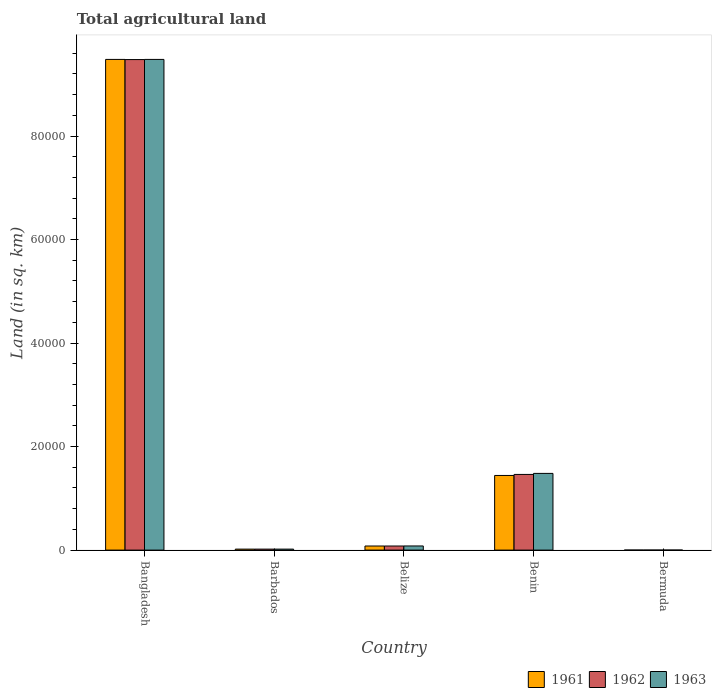How many different coloured bars are there?
Make the answer very short. 3. Are the number of bars on each tick of the X-axis equal?
Your answer should be compact. Yes. What is the label of the 2nd group of bars from the left?
Offer a very short reply. Barbados. What is the total agricultural land in 1963 in Benin?
Provide a short and direct response. 1.48e+04. Across all countries, what is the maximum total agricultural land in 1963?
Offer a very short reply. 9.48e+04. Across all countries, what is the minimum total agricultural land in 1963?
Your answer should be very brief. 3. In which country was the total agricultural land in 1963 maximum?
Provide a short and direct response. Bangladesh. In which country was the total agricultural land in 1961 minimum?
Give a very brief answer. Bermuda. What is the total total agricultural land in 1963 in the graph?
Ensure brevity in your answer.  1.11e+05. What is the difference between the total agricultural land in 1962 in Bangladesh and that in Benin?
Your answer should be compact. 8.02e+04. What is the difference between the total agricultural land in 1963 in Belize and the total agricultural land in 1961 in Bermuda?
Provide a succinct answer. 796. What is the average total agricultural land in 1962 per country?
Provide a short and direct response. 2.21e+04. What is the difference between the total agricultural land of/in 1962 and total agricultural land of/in 1963 in Belize?
Offer a terse response. -10. In how many countries, is the total agricultural land in 1963 greater than 92000 sq.km?
Offer a very short reply. 1. What is the ratio of the total agricultural land in 1962 in Belize to that in Benin?
Offer a very short reply. 0.05. Is the total agricultural land in 1962 in Bangladesh less than that in Bermuda?
Your response must be concise. No. Is the difference between the total agricultural land in 1962 in Bangladesh and Bermuda greater than the difference between the total agricultural land in 1963 in Bangladesh and Bermuda?
Make the answer very short. No. What is the difference between the highest and the second highest total agricultural land in 1962?
Offer a terse response. 8.02e+04. What is the difference between the highest and the lowest total agricultural land in 1963?
Your response must be concise. 9.48e+04. In how many countries, is the total agricultural land in 1962 greater than the average total agricultural land in 1962 taken over all countries?
Offer a very short reply. 1. What does the 1st bar from the left in Belize represents?
Provide a succinct answer. 1961. Are all the bars in the graph horizontal?
Your answer should be compact. No. How many countries are there in the graph?
Provide a succinct answer. 5. Are the values on the major ticks of Y-axis written in scientific E-notation?
Keep it short and to the point. No. Does the graph contain any zero values?
Keep it short and to the point. No. Does the graph contain grids?
Your answer should be compact. No. How are the legend labels stacked?
Make the answer very short. Horizontal. What is the title of the graph?
Give a very brief answer. Total agricultural land. What is the label or title of the X-axis?
Ensure brevity in your answer.  Country. What is the label or title of the Y-axis?
Make the answer very short. Land (in sq. km). What is the Land (in sq. km) of 1961 in Bangladesh?
Your response must be concise. 9.48e+04. What is the Land (in sq. km) in 1962 in Bangladesh?
Your response must be concise. 9.48e+04. What is the Land (in sq. km) in 1963 in Bangladesh?
Ensure brevity in your answer.  9.48e+04. What is the Land (in sq. km) of 1961 in Barbados?
Give a very brief answer. 190. What is the Land (in sq. km) of 1962 in Barbados?
Offer a very short reply. 190. What is the Land (in sq. km) of 1963 in Barbados?
Keep it short and to the point. 190. What is the Land (in sq. km) of 1961 in Belize?
Provide a succinct answer. 790. What is the Land (in sq. km) of 1962 in Belize?
Provide a succinct answer. 790. What is the Land (in sq. km) of 1963 in Belize?
Ensure brevity in your answer.  800. What is the Land (in sq. km) in 1961 in Benin?
Keep it short and to the point. 1.44e+04. What is the Land (in sq. km) in 1962 in Benin?
Your answer should be compact. 1.46e+04. What is the Land (in sq. km) of 1963 in Benin?
Keep it short and to the point. 1.48e+04. What is the Land (in sq. km) of 1962 in Bermuda?
Offer a very short reply. 3. What is the Land (in sq. km) of 1963 in Bermuda?
Your response must be concise. 3. Across all countries, what is the maximum Land (in sq. km) in 1961?
Keep it short and to the point. 9.48e+04. Across all countries, what is the maximum Land (in sq. km) in 1962?
Provide a succinct answer. 9.48e+04. Across all countries, what is the maximum Land (in sq. km) of 1963?
Provide a succinct answer. 9.48e+04. Across all countries, what is the minimum Land (in sq. km) of 1961?
Your answer should be compact. 4. Across all countries, what is the minimum Land (in sq. km) in 1962?
Keep it short and to the point. 3. What is the total Land (in sq. km) in 1961 in the graph?
Ensure brevity in your answer.  1.10e+05. What is the total Land (in sq. km) of 1962 in the graph?
Your answer should be very brief. 1.10e+05. What is the total Land (in sq. km) of 1963 in the graph?
Make the answer very short. 1.11e+05. What is the difference between the Land (in sq. km) of 1961 in Bangladesh and that in Barbados?
Ensure brevity in your answer.  9.46e+04. What is the difference between the Land (in sq. km) in 1962 in Bangladesh and that in Barbados?
Your answer should be very brief. 9.46e+04. What is the difference between the Land (in sq. km) in 1963 in Bangladesh and that in Barbados?
Offer a very short reply. 9.46e+04. What is the difference between the Land (in sq. km) in 1961 in Bangladesh and that in Belize?
Keep it short and to the point. 9.40e+04. What is the difference between the Land (in sq. km) in 1962 in Bangladesh and that in Belize?
Your answer should be very brief. 9.40e+04. What is the difference between the Land (in sq. km) of 1963 in Bangladesh and that in Belize?
Make the answer very short. 9.40e+04. What is the difference between the Land (in sq. km) in 1961 in Bangladesh and that in Benin?
Provide a short and direct response. 8.04e+04. What is the difference between the Land (in sq. km) of 1962 in Bangladesh and that in Benin?
Your answer should be very brief. 8.02e+04. What is the difference between the Land (in sq. km) of 1963 in Bangladesh and that in Benin?
Give a very brief answer. 8.00e+04. What is the difference between the Land (in sq. km) in 1961 in Bangladesh and that in Bermuda?
Offer a terse response. 9.48e+04. What is the difference between the Land (in sq. km) of 1962 in Bangladesh and that in Bermuda?
Your response must be concise. 9.48e+04. What is the difference between the Land (in sq. km) of 1963 in Bangladesh and that in Bermuda?
Ensure brevity in your answer.  9.48e+04. What is the difference between the Land (in sq. km) in 1961 in Barbados and that in Belize?
Give a very brief answer. -600. What is the difference between the Land (in sq. km) of 1962 in Barbados and that in Belize?
Your answer should be compact. -600. What is the difference between the Land (in sq. km) in 1963 in Barbados and that in Belize?
Your response must be concise. -610. What is the difference between the Land (in sq. km) of 1961 in Barbados and that in Benin?
Keep it short and to the point. -1.42e+04. What is the difference between the Land (in sq. km) in 1962 in Barbados and that in Benin?
Offer a very short reply. -1.44e+04. What is the difference between the Land (in sq. km) in 1963 in Barbados and that in Benin?
Your answer should be compact. -1.46e+04. What is the difference between the Land (in sq. km) of 1961 in Barbados and that in Bermuda?
Keep it short and to the point. 186. What is the difference between the Land (in sq. km) of 1962 in Barbados and that in Bermuda?
Offer a very short reply. 187. What is the difference between the Land (in sq. km) in 1963 in Barbados and that in Bermuda?
Provide a succinct answer. 187. What is the difference between the Land (in sq. km) in 1961 in Belize and that in Benin?
Your response must be concise. -1.36e+04. What is the difference between the Land (in sq. km) of 1962 in Belize and that in Benin?
Keep it short and to the point. -1.38e+04. What is the difference between the Land (in sq. km) of 1963 in Belize and that in Benin?
Provide a succinct answer. -1.40e+04. What is the difference between the Land (in sq. km) in 1961 in Belize and that in Bermuda?
Your answer should be compact. 786. What is the difference between the Land (in sq. km) of 1962 in Belize and that in Bermuda?
Keep it short and to the point. 787. What is the difference between the Land (in sq. km) in 1963 in Belize and that in Bermuda?
Offer a very short reply. 797. What is the difference between the Land (in sq. km) of 1961 in Benin and that in Bermuda?
Give a very brief answer. 1.44e+04. What is the difference between the Land (in sq. km) in 1962 in Benin and that in Bermuda?
Offer a terse response. 1.46e+04. What is the difference between the Land (in sq. km) of 1963 in Benin and that in Bermuda?
Provide a short and direct response. 1.48e+04. What is the difference between the Land (in sq. km) of 1961 in Bangladesh and the Land (in sq. km) of 1962 in Barbados?
Provide a succinct answer. 9.46e+04. What is the difference between the Land (in sq. km) in 1961 in Bangladesh and the Land (in sq. km) in 1963 in Barbados?
Offer a terse response. 9.46e+04. What is the difference between the Land (in sq. km) of 1962 in Bangladesh and the Land (in sq. km) of 1963 in Barbados?
Your answer should be very brief. 9.46e+04. What is the difference between the Land (in sq. km) of 1961 in Bangladesh and the Land (in sq. km) of 1962 in Belize?
Keep it short and to the point. 9.40e+04. What is the difference between the Land (in sq. km) in 1961 in Bangladesh and the Land (in sq. km) in 1963 in Belize?
Your answer should be compact. 9.40e+04. What is the difference between the Land (in sq. km) of 1962 in Bangladesh and the Land (in sq. km) of 1963 in Belize?
Ensure brevity in your answer.  9.40e+04. What is the difference between the Land (in sq. km) of 1961 in Bangladesh and the Land (in sq. km) of 1962 in Benin?
Give a very brief answer. 8.02e+04. What is the difference between the Land (in sq. km) in 1961 in Bangladesh and the Land (in sq. km) in 1963 in Benin?
Make the answer very short. 8.00e+04. What is the difference between the Land (in sq. km) in 1962 in Bangladesh and the Land (in sq. km) in 1963 in Benin?
Offer a very short reply. 8.00e+04. What is the difference between the Land (in sq. km) of 1961 in Bangladesh and the Land (in sq. km) of 1962 in Bermuda?
Your response must be concise. 9.48e+04. What is the difference between the Land (in sq. km) in 1961 in Bangladesh and the Land (in sq. km) in 1963 in Bermuda?
Provide a succinct answer. 9.48e+04. What is the difference between the Land (in sq. km) in 1962 in Bangladesh and the Land (in sq. km) in 1963 in Bermuda?
Give a very brief answer. 9.48e+04. What is the difference between the Land (in sq. km) in 1961 in Barbados and the Land (in sq. km) in 1962 in Belize?
Your response must be concise. -600. What is the difference between the Land (in sq. km) in 1961 in Barbados and the Land (in sq. km) in 1963 in Belize?
Offer a terse response. -610. What is the difference between the Land (in sq. km) of 1962 in Barbados and the Land (in sq. km) of 1963 in Belize?
Give a very brief answer. -610. What is the difference between the Land (in sq. km) in 1961 in Barbados and the Land (in sq. km) in 1962 in Benin?
Your answer should be compact. -1.44e+04. What is the difference between the Land (in sq. km) of 1961 in Barbados and the Land (in sq. km) of 1963 in Benin?
Ensure brevity in your answer.  -1.46e+04. What is the difference between the Land (in sq. km) in 1962 in Barbados and the Land (in sq. km) in 1963 in Benin?
Your answer should be compact. -1.46e+04. What is the difference between the Land (in sq. km) of 1961 in Barbados and the Land (in sq. km) of 1962 in Bermuda?
Your answer should be compact. 187. What is the difference between the Land (in sq. km) in 1961 in Barbados and the Land (in sq. km) in 1963 in Bermuda?
Provide a short and direct response. 187. What is the difference between the Land (in sq. km) of 1962 in Barbados and the Land (in sq. km) of 1963 in Bermuda?
Give a very brief answer. 187. What is the difference between the Land (in sq. km) in 1961 in Belize and the Land (in sq. km) in 1962 in Benin?
Ensure brevity in your answer.  -1.38e+04. What is the difference between the Land (in sq. km) of 1961 in Belize and the Land (in sq. km) of 1963 in Benin?
Keep it short and to the point. -1.40e+04. What is the difference between the Land (in sq. km) in 1962 in Belize and the Land (in sq. km) in 1963 in Benin?
Your answer should be very brief. -1.40e+04. What is the difference between the Land (in sq. km) in 1961 in Belize and the Land (in sq. km) in 1962 in Bermuda?
Keep it short and to the point. 787. What is the difference between the Land (in sq. km) in 1961 in Belize and the Land (in sq. km) in 1963 in Bermuda?
Provide a short and direct response. 787. What is the difference between the Land (in sq. km) of 1962 in Belize and the Land (in sq. km) of 1963 in Bermuda?
Provide a succinct answer. 787. What is the difference between the Land (in sq. km) of 1961 in Benin and the Land (in sq. km) of 1962 in Bermuda?
Your answer should be very brief. 1.44e+04. What is the difference between the Land (in sq. km) in 1961 in Benin and the Land (in sq. km) in 1963 in Bermuda?
Your answer should be compact. 1.44e+04. What is the difference between the Land (in sq. km) in 1962 in Benin and the Land (in sq. km) in 1963 in Bermuda?
Offer a very short reply. 1.46e+04. What is the average Land (in sq. km) in 1961 per country?
Your answer should be very brief. 2.20e+04. What is the average Land (in sq. km) in 1962 per country?
Your response must be concise. 2.21e+04. What is the average Land (in sq. km) of 1963 per country?
Your answer should be compact. 2.21e+04. What is the difference between the Land (in sq. km) in 1961 and Land (in sq. km) in 1962 in Bangladesh?
Provide a succinct answer. 30. What is the difference between the Land (in sq. km) in 1961 and Land (in sq. km) in 1962 in Barbados?
Your answer should be very brief. 0. What is the difference between the Land (in sq. km) in 1961 and Land (in sq. km) in 1963 in Barbados?
Offer a very short reply. 0. What is the difference between the Land (in sq. km) in 1961 and Land (in sq. km) in 1962 in Benin?
Keep it short and to the point. -200. What is the difference between the Land (in sq. km) in 1961 and Land (in sq. km) in 1963 in Benin?
Keep it short and to the point. -400. What is the difference between the Land (in sq. km) in 1962 and Land (in sq. km) in 1963 in Benin?
Give a very brief answer. -200. What is the ratio of the Land (in sq. km) of 1961 in Bangladesh to that in Barbados?
Offer a terse response. 498.95. What is the ratio of the Land (in sq. km) in 1962 in Bangladesh to that in Barbados?
Your answer should be very brief. 498.79. What is the ratio of the Land (in sq. km) in 1963 in Bangladesh to that in Barbados?
Offer a very short reply. 498.95. What is the ratio of the Land (in sq. km) in 1961 in Bangladesh to that in Belize?
Make the answer very short. 120. What is the ratio of the Land (in sq. km) of 1962 in Bangladesh to that in Belize?
Keep it short and to the point. 119.96. What is the ratio of the Land (in sq. km) in 1963 in Bangladesh to that in Belize?
Your answer should be compact. 118.5. What is the ratio of the Land (in sq. km) of 1961 in Bangladesh to that in Benin?
Ensure brevity in your answer.  6.57. What is the ratio of the Land (in sq. km) in 1962 in Bangladesh to that in Benin?
Your answer should be compact. 6.48. What is the ratio of the Land (in sq. km) in 1963 in Bangladesh to that in Benin?
Your answer should be compact. 6.4. What is the ratio of the Land (in sq. km) of 1961 in Bangladesh to that in Bermuda?
Your answer should be very brief. 2.37e+04. What is the ratio of the Land (in sq. km) of 1962 in Bangladesh to that in Bermuda?
Keep it short and to the point. 3.16e+04. What is the ratio of the Land (in sq. km) in 1963 in Bangladesh to that in Bermuda?
Provide a succinct answer. 3.16e+04. What is the ratio of the Land (in sq. km) in 1961 in Barbados to that in Belize?
Make the answer very short. 0.24. What is the ratio of the Land (in sq. km) of 1962 in Barbados to that in Belize?
Your response must be concise. 0.24. What is the ratio of the Land (in sq. km) in 1963 in Barbados to that in Belize?
Keep it short and to the point. 0.24. What is the ratio of the Land (in sq. km) of 1961 in Barbados to that in Benin?
Keep it short and to the point. 0.01. What is the ratio of the Land (in sq. km) in 1962 in Barbados to that in Benin?
Your answer should be very brief. 0.01. What is the ratio of the Land (in sq. km) of 1963 in Barbados to that in Benin?
Your answer should be compact. 0.01. What is the ratio of the Land (in sq. km) in 1961 in Barbados to that in Bermuda?
Give a very brief answer. 47.5. What is the ratio of the Land (in sq. km) in 1962 in Barbados to that in Bermuda?
Provide a succinct answer. 63.33. What is the ratio of the Land (in sq. km) in 1963 in Barbados to that in Bermuda?
Ensure brevity in your answer.  63.33. What is the ratio of the Land (in sq. km) in 1961 in Belize to that in Benin?
Your answer should be compact. 0.05. What is the ratio of the Land (in sq. km) in 1962 in Belize to that in Benin?
Your answer should be very brief. 0.05. What is the ratio of the Land (in sq. km) of 1963 in Belize to that in Benin?
Your answer should be compact. 0.05. What is the ratio of the Land (in sq. km) in 1961 in Belize to that in Bermuda?
Make the answer very short. 197.5. What is the ratio of the Land (in sq. km) of 1962 in Belize to that in Bermuda?
Make the answer very short. 263.33. What is the ratio of the Land (in sq. km) in 1963 in Belize to that in Bermuda?
Your response must be concise. 266.67. What is the ratio of the Land (in sq. km) of 1961 in Benin to that in Bermuda?
Your response must be concise. 3605. What is the ratio of the Land (in sq. km) in 1962 in Benin to that in Bermuda?
Your answer should be very brief. 4873.33. What is the ratio of the Land (in sq. km) in 1963 in Benin to that in Bermuda?
Make the answer very short. 4940. What is the difference between the highest and the second highest Land (in sq. km) of 1961?
Offer a very short reply. 8.04e+04. What is the difference between the highest and the second highest Land (in sq. km) in 1962?
Your answer should be very brief. 8.02e+04. What is the difference between the highest and the second highest Land (in sq. km) in 1963?
Offer a very short reply. 8.00e+04. What is the difference between the highest and the lowest Land (in sq. km) in 1961?
Provide a succinct answer. 9.48e+04. What is the difference between the highest and the lowest Land (in sq. km) in 1962?
Ensure brevity in your answer.  9.48e+04. What is the difference between the highest and the lowest Land (in sq. km) in 1963?
Offer a very short reply. 9.48e+04. 